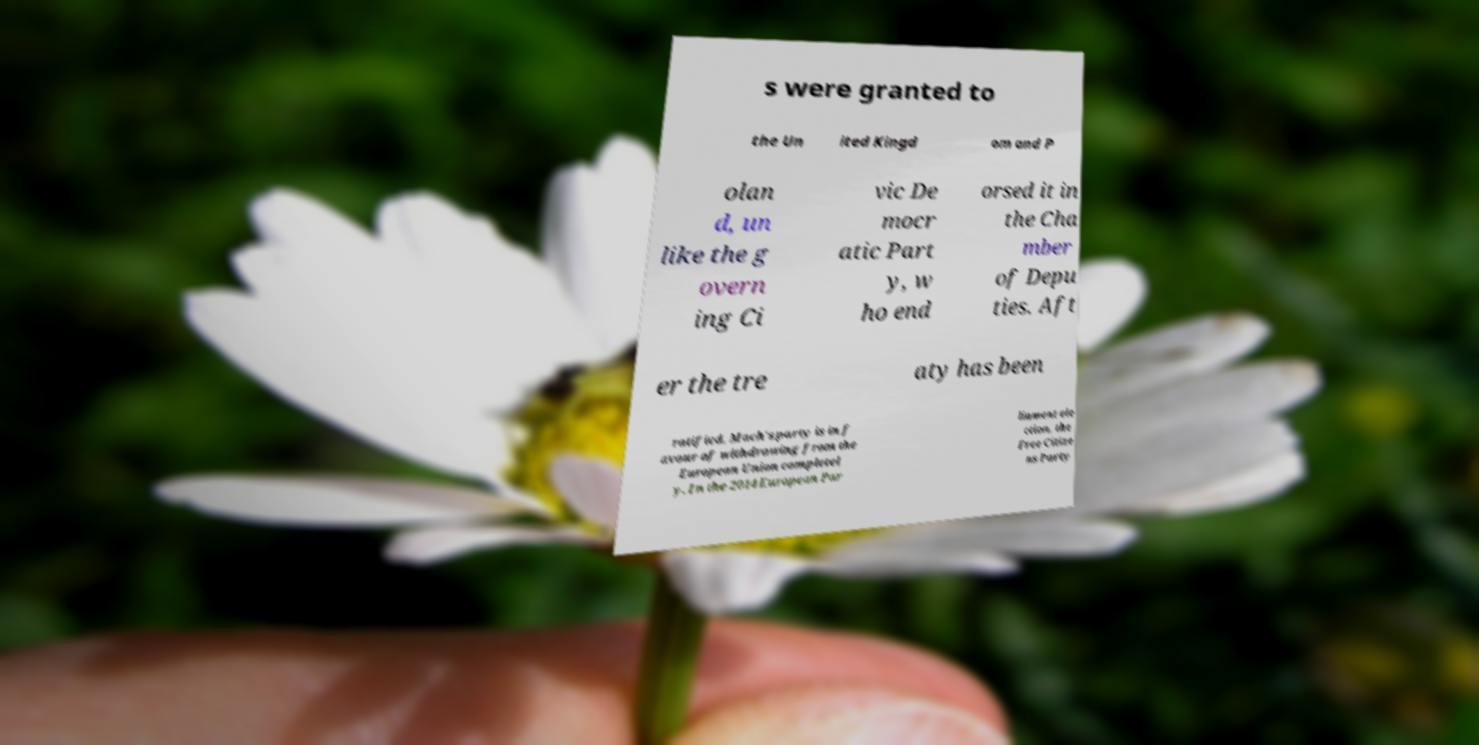Could you extract and type out the text from this image? s were granted to the Un ited Kingd om and P olan d, un like the g overn ing Ci vic De mocr atic Part y, w ho end orsed it in the Cha mber of Depu ties. Aft er the tre aty has been ratified, Mach's party is in f avour of withdrawing from the European Union completel y. In the 2014 European Par liament ele ction, the Free Citize ns Party 